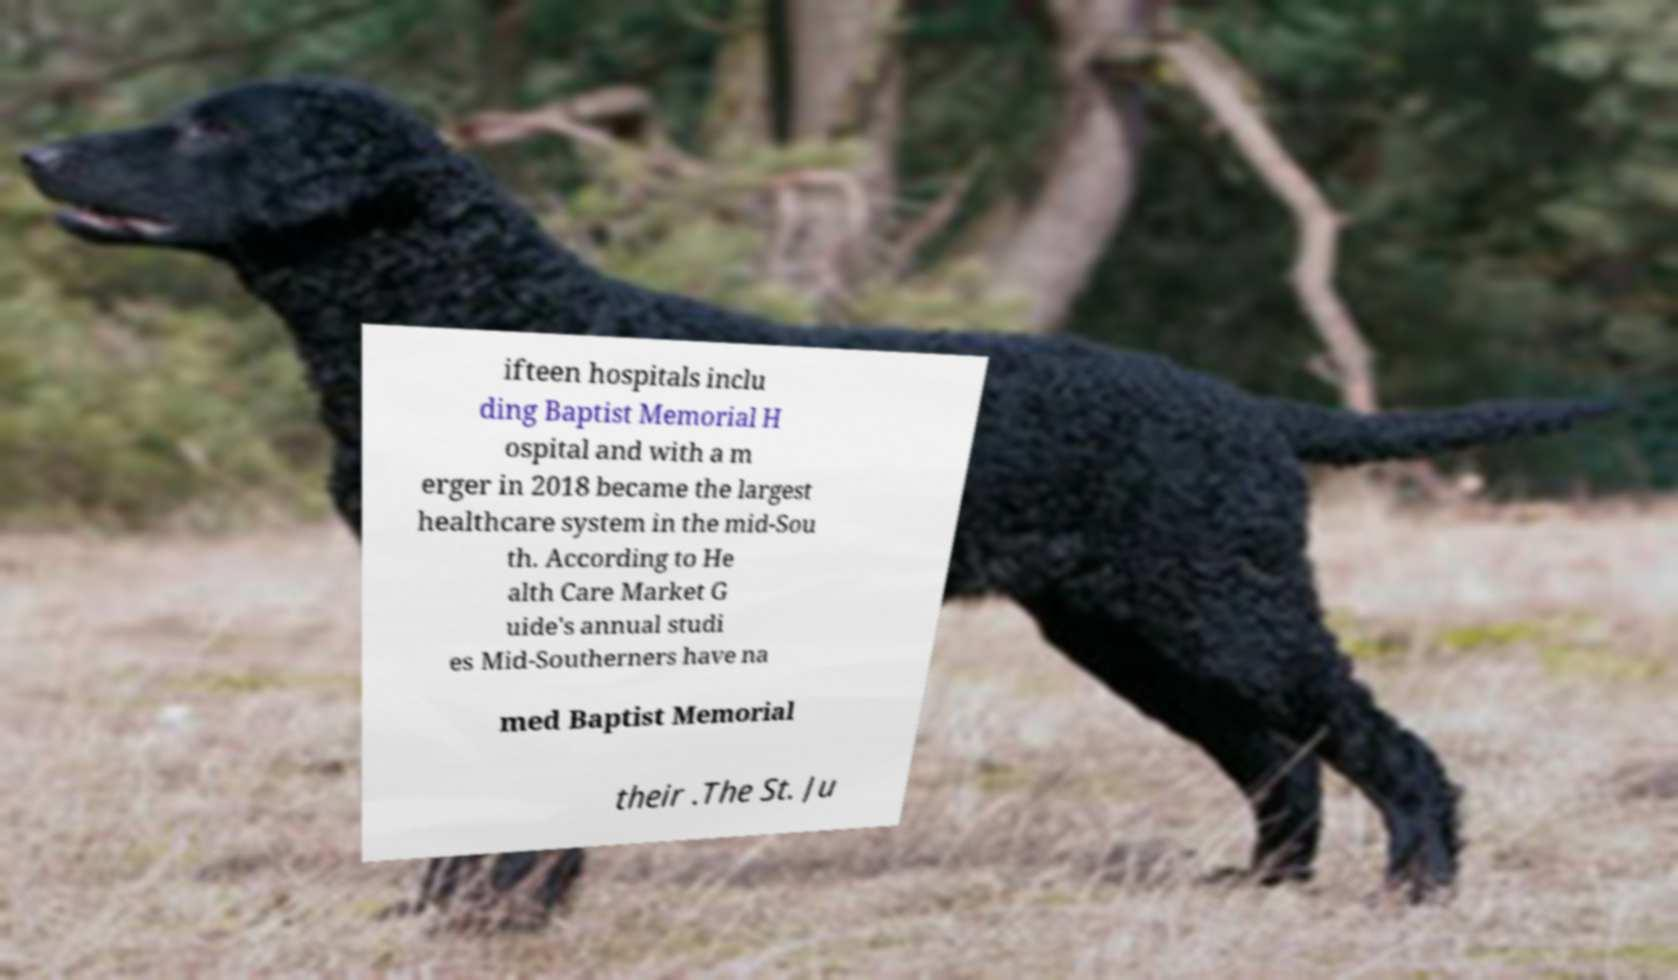Could you assist in decoding the text presented in this image and type it out clearly? ifteen hospitals inclu ding Baptist Memorial H ospital and with a m erger in 2018 became the largest healthcare system in the mid-Sou th. According to He alth Care Market G uide's annual studi es Mid-Southerners have na med Baptist Memorial their .The St. Ju 